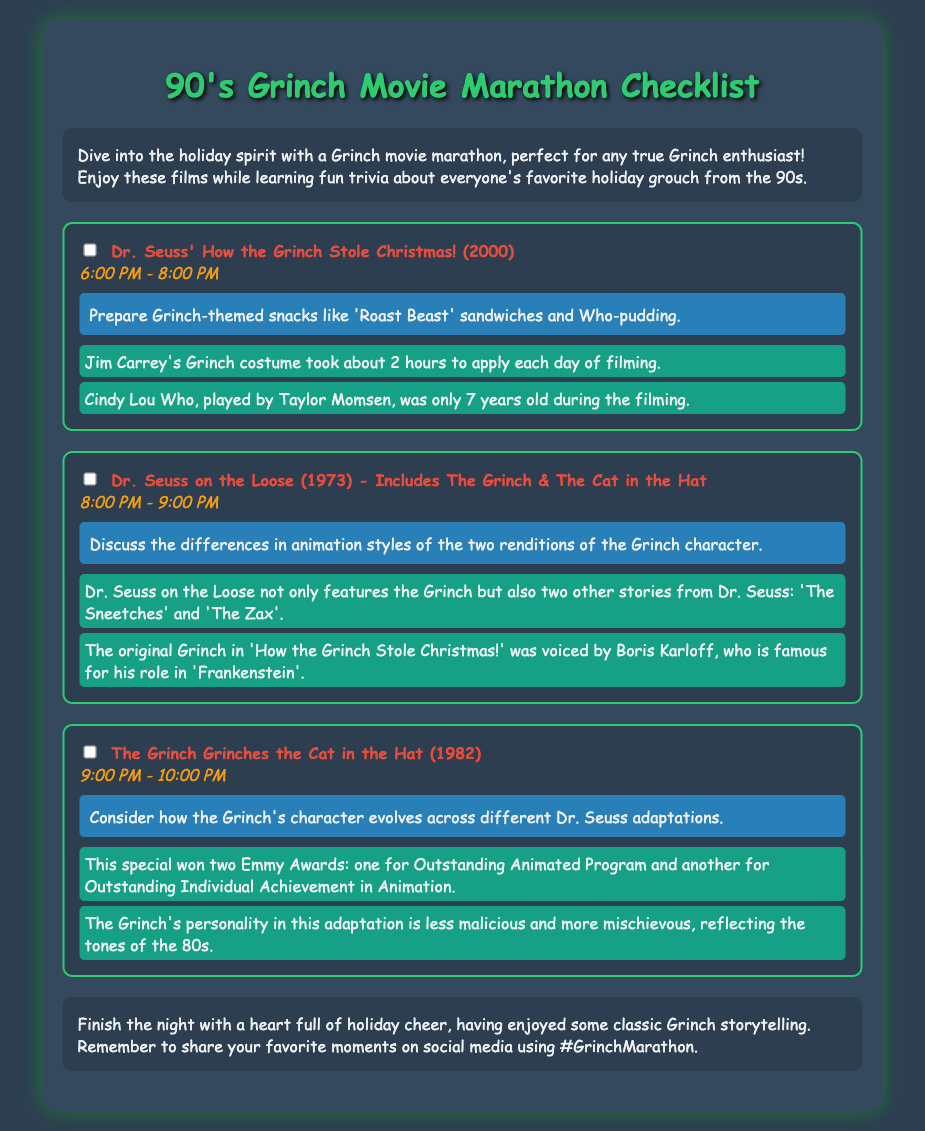what is the first movie in the marathon? The first movie listed in the checklist is 'Dr. Seuss' How the Grinch Stole Christmas! (2000)'.
Answer: Dr. Seuss' How the Grinch Stole Christmas! (2000) what time does the second movie start? The second movie, 'Dr. Seuss on the Loose', starts at 8:00 PM.
Answer: 8:00 PM how long is the Grinch's costume application time? The trivia states that Jim Carrey's Grinch costume took about 2 hours to apply each day of filming.
Answer: 2 hours which movie won two Emmy Awards? The document mentions that 'The Grinch Grinches the Cat in the Hat' won two Emmy Awards.
Answer: The Grinch Grinches the Cat in the Hat what snacks are suggested for the first movie? The reminder for the first movie suggests preparing Grinch-themed snacks like 'Roast Beast' sandwiches and Who-pudding.
Answer: 'Roast Beast' sandwiches and Who-pudding how many movies are listed in the checklist? The document lists a total of three movies for the marathon.
Answer: three 